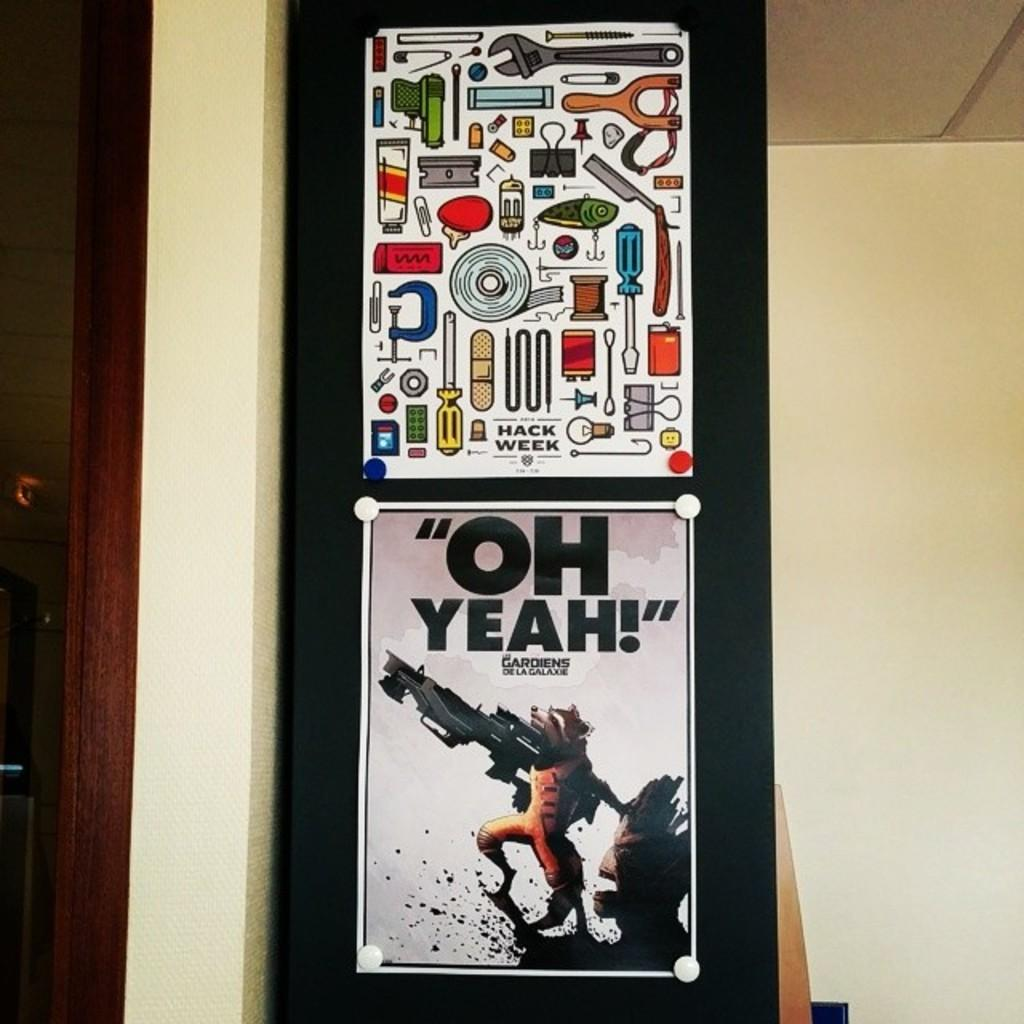<image>
Provide a brief description of the given image. A poster that says "Oh Yeah!" shows a raccoon with a huge gun. 